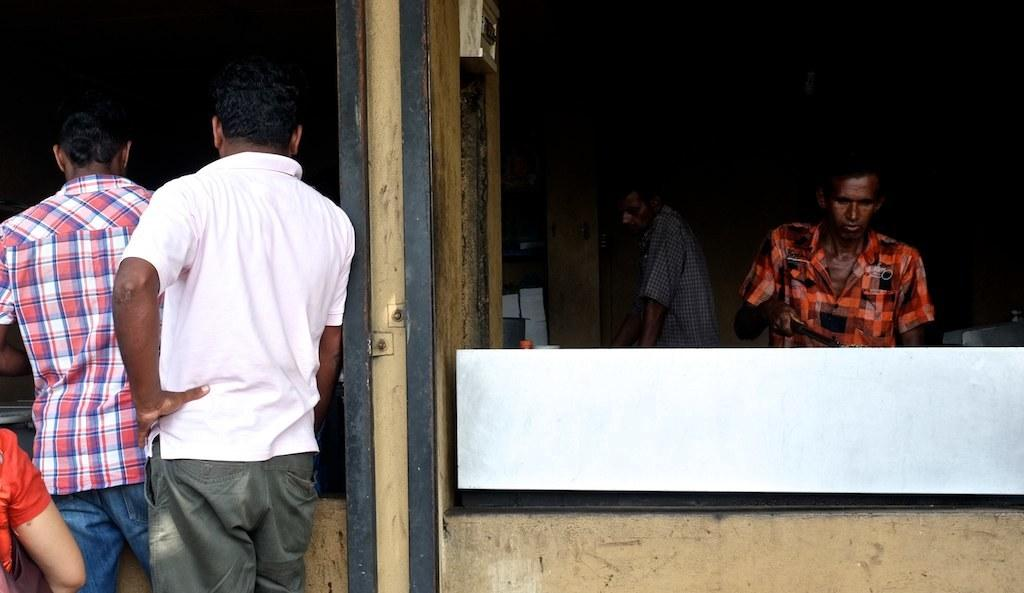How many people are in the image? There are persons standing in the image. What is one of the persons doing in the image? There is a person holding an object in the image. What can be seen in the background of the image? There is a switch board in the image. What type of property is being judged by the chair in the image? There is no chair or property present in the image. 